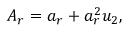<formula> <loc_0><loc_0><loc_500><loc_500>A _ { r } = a _ { r } + a _ { r } ^ { 2 } u _ { 2 } ,</formula> 